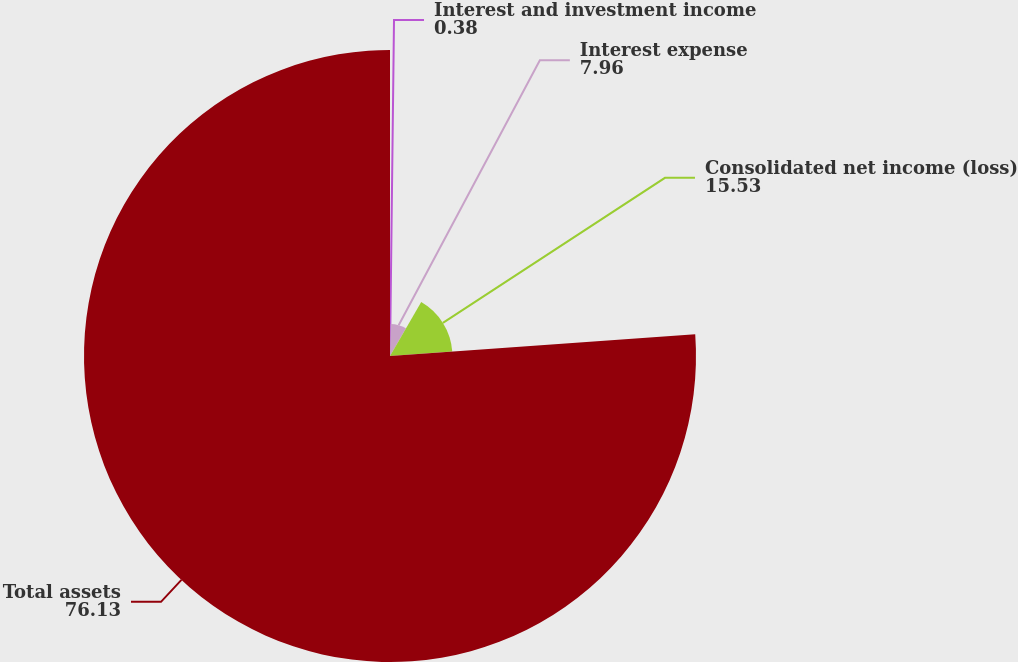<chart> <loc_0><loc_0><loc_500><loc_500><pie_chart><fcel>Interest and investment income<fcel>Interest expense<fcel>Consolidated net income (loss)<fcel>Total assets<nl><fcel>0.38%<fcel>7.96%<fcel>15.53%<fcel>76.13%<nl></chart> 